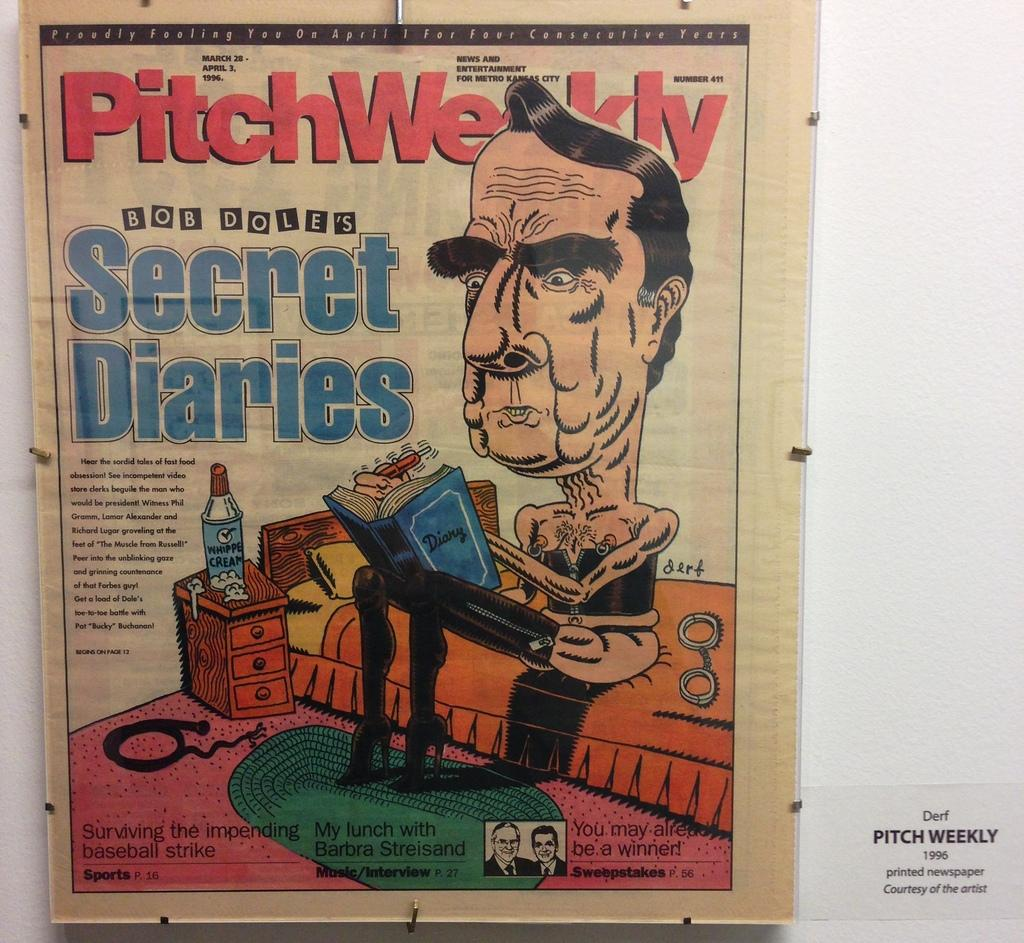<image>
Summarize the visual content of the image. A cartoon of Bob Dole on a 1996 Pitch Weekly cover. 